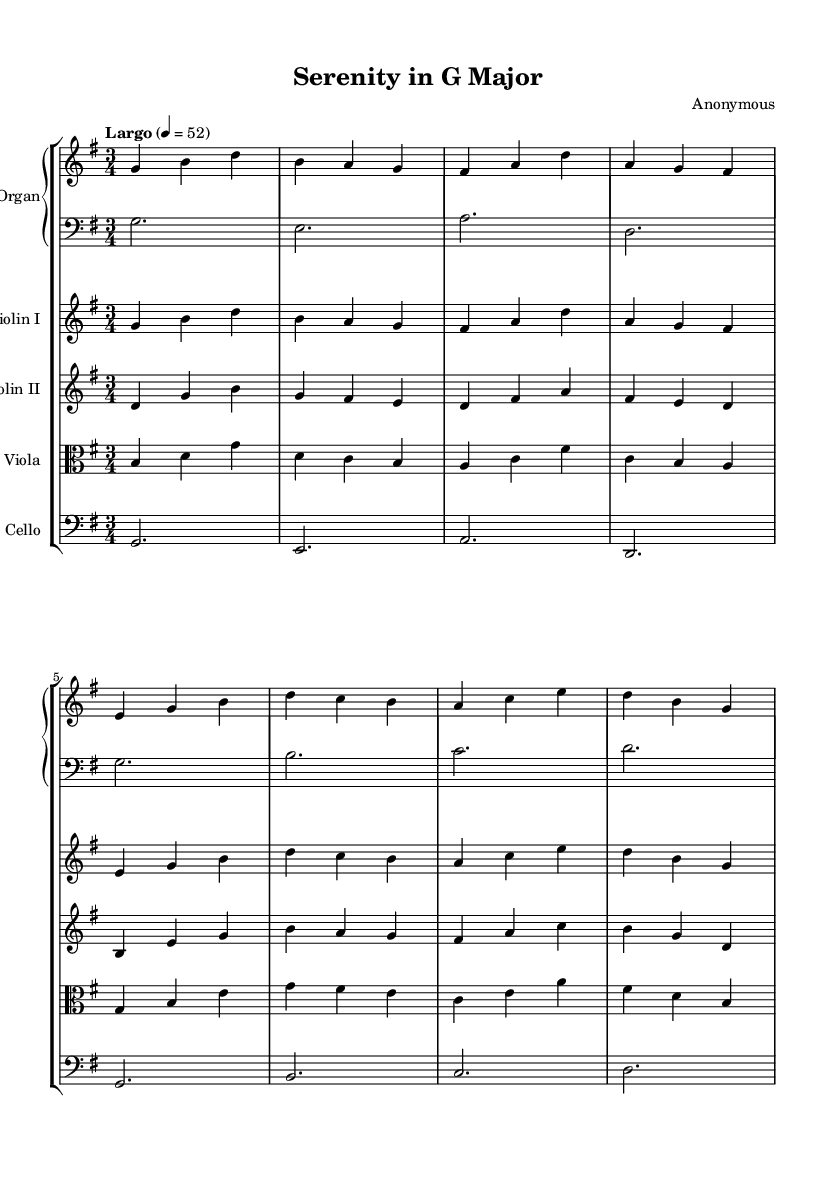What is the key signature of this music? The key signature is G major, which has one sharp (F#) indicated by the key signature at the beginning of the staff.
Answer: G major What is the time signature of this piece? The time signature is 3/4, indicated just after the key signature at the beginning of the staff. This means there are three beats in each measure, and the quarter note gets one beat.
Answer: 3/4 What is the tempo marking of this composition? The tempo marking is "Largo," indicated above the staff, which suggests a slow and dignified pace. The metronome marking "4 = 52" indicates the speed in beats per minute.
Answer: Largo How many measures are in this piece? Counting the measures in the score, there are 16 measures present. Each group of notes separated by vertical lines indicates a measure.
Answer: 16 What instruments are included in this arrangement? The arrangement includes organ, violin I, violin II, viola, and cello, as indicated at the beginning of each staff.
Answer: Organ, violin I, violin II, viola, cello Which voice has the highest pitch throughout the piece? The violin I part consistently plays the highest pitches in comparison to the other instruments, evidenced by its positioning on the staff and the notes used.
Answer: Violin I What is the overall mood or purpose of this piece of music? The piece is intended for calming and meditation, as indicated by its traditions within Baroque sacred music, commonly used for inner peace and reflection.
Answer: Calming 